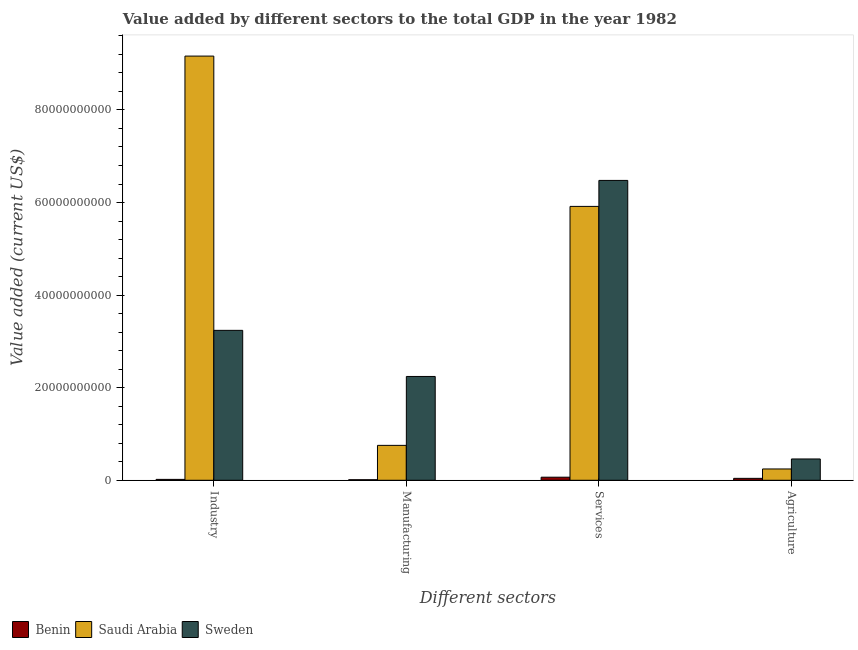How many groups of bars are there?
Provide a short and direct response. 4. Are the number of bars on each tick of the X-axis equal?
Offer a terse response. Yes. What is the label of the 2nd group of bars from the left?
Provide a succinct answer. Manufacturing. What is the value added by agricultural sector in Sweden?
Make the answer very short. 4.60e+09. Across all countries, what is the maximum value added by manufacturing sector?
Ensure brevity in your answer.  2.24e+1. Across all countries, what is the minimum value added by industrial sector?
Provide a short and direct response. 1.92e+08. In which country was the value added by services sector minimum?
Keep it short and to the point. Benin. What is the total value added by industrial sector in the graph?
Provide a succinct answer. 1.24e+11. What is the difference between the value added by agricultural sector in Benin and that in Saudi Arabia?
Provide a succinct answer. -2.03e+09. What is the difference between the value added by industrial sector in Saudi Arabia and the value added by agricultural sector in Sweden?
Offer a terse response. 8.70e+1. What is the average value added by industrial sector per country?
Your answer should be very brief. 4.14e+1. What is the difference between the value added by services sector and value added by industrial sector in Benin?
Your answer should be compact. 4.72e+08. In how many countries, is the value added by agricultural sector greater than 40000000000 US$?
Offer a very short reply. 0. What is the ratio of the value added by agricultural sector in Sweden to that in Saudi Arabia?
Offer a very short reply. 1.88. What is the difference between the highest and the second highest value added by agricultural sector?
Ensure brevity in your answer.  2.16e+09. What is the difference between the highest and the lowest value added by services sector?
Ensure brevity in your answer.  6.41e+1. Is the sum of the value added by industrial sector in Saudi Arabia and Benin greater than the maximum value added by manufacturing sector across all countries?
Ensure brevity in your answer.  Yes. Is it the case that in every country, the sum of the value added by agricultural sector and value added by industrial sector is greater than the sum of value added by manufacturing sector and value added by services sector?
Make the answer very short. No. What does the 1st bar from the right in Agriculture represents?
Your response must be concise. Sweden. How many bars are there?
Ensure brevity in your answer.  12. Does the graph contain any zero values?
Ensure brevity in your answer.  No. Where does the legend appear in the graph?
Make the answer very short. Bottom left. What is the title of the graph?
Ensure brevity in your answer.  Value added by different sectors to the total GDP in the year 1982. Does "Equatorial Guinea" appear as one of the legend labels in the graph?
Your response must be concise. No. What is the label or title of the X-axis?
Make the answer very short. Different sectors. What is the label or title of the Y-axis?
Keep it short and to the point. Value added (current US$). What is the Value added (current US$) of Benin in Industry?
Your answer should be compact. 1.92e+08. What is the Value added (current US$) of Saudi Arabia in Industry?
Provide a succinct answer. 9.16e+1. What is the Value added (current US$) in Sweden in Industry?
Ensure brevity in your answer.  3.24e+1. What is the Value added (current US$) in Benin in Manufacturing?
Make the answer very short. 1.15e+08. What is the Value added (current US$) in Saudi Arabia in Manufacturing?
Give a very brief answer. 7.54e+09. What is the Value added (current US$) of Sweden in Manufacturing?
Your response must be concise. 2.24e+1. What is the Value added (current US$) in Benin in Services?
Provide a short and direct response. 6.64e+08. What is the Value added (current US$) in Saudi Arabia in Services?
Make the answer very short. 5.92e+1. What is the Value added (current US$) in Sweden in Services?
Your answer should be compact. 6.48e+1. What is the Value added (current US$) of Benin in Agriculture?
Ensure brevity in your answer.  4.12e+08. What is the Value added (current US$) in Saudi Arabia in Agriculture?
Offer a very short reply. 2.44e+09. What is the Value added (current US$) of Sweden in Agriculture?
Provide a succinct answer. 4.60e+09. Across all Different sectors, what is the maximum Value added (current US$) of Benin?
Your answer should be very brief. 6.64e+08. Across all Different sectors, what is the maximum Value added (current US$) in Saudi Arabia?
Your answer should be compact. 9.16e+1. Across all Different sectors, what is the maximum Value added (current US$) of Sweden?
Provide a short and direct response. 6.48e+1. Across all Different sectors, what is the minimum Value added (current US$) of Benin?
Offer a very short reply. 1.15e+08. Across all Different sectors, what is the minimum Value added (current US$) in Saudi Arabia?
Provide a short and direct response. 2.44e+09. Across all Different sectors, what is the minimum Value added (current US$) of Sweden?
Provide a succinct answer. 4.60e+09. What is the total Value added (current US$) of Benin in the graph?
Provide a short and direct response. 1.38e+09. What is the total Value added (current US$) in Saudi Arabia in the graph?
Ensure brevity in your answer.  1.61e+11. What is the total Value added (current US$) of Sweden in the graph?
Keep it short and to the point. 1.24e+11. What is the difference between the Value added (current US$) in Benin in Industry and that in Manufacturing?
Offer a very short reply. 7.64e+07. What is the difference between the Value added (current US$) in Saudi Arabia in Industry and that in Manufacturing?
Give a very brief answer. 8.41e+1. What is the difference between the Value added (current US$) of Sweden in Industry and that in Manufacturing?
Keep it short and to the point. 9.96e+09. What is the difference between the Value added (current US$) of Benin in Industry and that in Services?
Offer a terse response. -4.72e+08. What is the difference between the Value added (current US$) in Saudi Arabia in Industry and that in Services?
Offer a terse response. 3.25e+1. What is the difference between the Value added (current US$) in Sweden in Industry and that in Services?
Your response must be concise. -3.24e+1. What is the difference between the Value added (current US$) in Benin in Industry and that in Agriculture?
Ensure brevity in your answer.  -2.20e+08. What is the difference between the Value added (current US$) of Saudi Arabia in Industry and that in Agriculture?
Ensure brevity in your answer.  8.92e+1. What is the difference between the Value added (current US$) in Sweden in Industry and that in Agriculture?
Your response must be concise. 2.78e+1. What is the difference between the Value added (current US$) of Benin in Manufacturing and that in Services?
Your response must be concise. -5.49e+08. What is the difference between the Value added (current US$) in Saudi Arabia in Manufacturing and that in Services?
Ensure brevity in your answer.  -5.16e+1. What is the difference between the Value added (current US$) in Sweden in Manufacturing and that in Services?
Provide a short and direct response. -4.24e+1. What is the difference between the Value added (current US$) in Benin in Manufacturing and that in Agriculture?
Give a very brief answer. -2.97e+08. What is the difference between the Value added (current US$) of Saudi Arabia in Manufacturing and that in Agriculture?
Ensure brevity in your answer.  5.10e+09. What is the difference between the Value added (current US$) of Sweden in Manufacturing and that in Agriculture?
Ensure brevity in your answer.  1.78e+1. What is the difference between the Value added (current US$) of Benin in Services and that in Agriculture?
Keep it short and to the point. 2.52e+08. What is the difference between the Value added (current US$) in Saudi Arabia in Services and that in Agriculture?
Ensure brevity in your answer.  5.67e+1. What is the difference between the Value added (current US$) of Sweden in Services and that in Agriculture?
Your answer should be compact. 6.02e+1. What is the difference between the Value added (current US$) of Benin in Industry and the Value added (current US$) of Saudi Arabia in Manufacturing?
Provide a short and direct response. -7.35e+09. What is the difference between the Value added (current US$) in Benin in Industry and the Value added (current US$) in Sweden in Manufacturing?
Your answer should be compact. -2.22e+1. What is the difference between the Value added (current US$) in Saudi Arabia in Industry and the Value added (current US$) in Sweden in Manufacturing?
Keep it short and to the point. 6.92e+1. What is the difference between the Value added (current US$) of Benin in Industry and the Value added (current US$) of Saudi Arabia in Services?
Make the answer very short. -5.90e+1. What is the difference between the Value added (current US$) of Benin in Industry and the Value added (current US$) of Sweden in Services?
Keep it short and to the point. -6.46e+1. What is the difference between the Value added (current US$) of Saudi Arabia in Industry and the Value added (current US$) of Sweden in Services?
Ensure brevity in your answer.  2.69e+1. What is the difference between the Value added (current US$) in Benin in Industry and the Value added (current US$) in Saudi Arabia in Agriculture?
Your response must be concise. -2.25e+09. What is the difference between the Value added (current US$) of Benin in Industry and the Value added (current US$) of Sweden in Agriculture?
Your answer should be very brief. -4.41e+09. What is the difference between the Value added (current US$) in Saudi Arabia in Industry and the Value added (current US$) in Sweden in Agriculture?
Your answer should be very brief. 8.70e+1. What is the difference between the Value added (current US$) in Benin in Manufacturing and the Value added (current US$) in Saudi Arabia in Services?
Your answer should be compact. -5.90e+1. What is the difference between the Value added (current US$) of Benin in Manufacturing and the Value added (current US$) of Sweden in Services?
Provide a short and direct response. -6.47e+1. What is the difference between the Value added (current US$) in Saudi Arabia in Manufacturing and the Value added (current US$) in Sweden in Services?
Offer a very short reply. -5.72e+1. What is the difference between the Value added (current US$) in Benin in Manufacturing and the Value added (current US$) in Saudi Arabia in Agriculture?
Give a very brief answer. -2.33e+09. What is the difference between the Value added (current US$) of Benin in Manufacturing and the Value added (current US$) of Sweden in Agriculture?
Your answer should be compact. -4.49e+09. What is the difference between the Value added (current US$) of Saudi Arabia in Manufacturing and the Value added (current US$) of Sweden in Agriculture?
Your response must be concise. 2.94e+09. What is the difference between the Value added (current US$) in Benin in Services and the Value added (current US$) in Saudi Arabia in Agriculture?
Provide a succinct answer. -1.78e+09. What is the difference between the Value added (current US$) in Benin in Services and the Value added (current US$) in Sweden in Agriculture?
Provide a short and direct response. -3.94e+09. What is the difference between the Value added (current US$) in Saudi Arabia in Services and the Value added (current US$) in Sweden in Agriculture?
Your response must be concise. 5.46e+1. What is the average Value added (current US$) of Benin per Different sectors?
Give a very brief answer. 3.46e+08. What is the average Value added (current US$) of Saudi Arabia per Different sectors?
Provide a short and direct response. 4.02e+1. What is the average Value added (current US$) in Sweden per Different sectors?
Make the answer very short. 3.10e+1. What is the difference between the Value added (current US$) of Benin and Value added (current US$) of Saudi Arabia in Industry?
Offer a terse response. -9.14e+1. What is the difference between the Value added (current US$) in Benin and Value added (current US$) in Sweden in Industry?
Offer a very short reply. -3.22e+1. What is the difference between the Value added (current US$) of Saudi Arabia and Value added (current US$) of Sweden in Industry?
Your response must be concise. 5.92e+1. What is the difference between the Value added (current US$) in Benin and Value added (current US$) in Saudi Arabia in Manufacturing?
Your answer should be very brief. -7.42e+09. What is the difference between the Value added (current US$) in Benin and Value added (current US$) in Sweden in Manufacturing?
Ensure brevity in your answer.  -2.23e+1. What is the difference between the Value added (current US$) in Saudi Arabia and Value added (current US$) in Sweden in Manufacturing?
Offer a very short reply. -1.49e+1. What is the difference between the Value added (current US$) of Benin and Value added (current US$) of Saudi Arabia in Services?
Make the answer very short. -5.85e+1. What is the difference between the Value added (current US$) of Benin and Value added (current US$) of Sweden in Services?
Keep it short and to the point. -6.41e+1. What is the difference between the Value added (current US$) in Saudi Arabia and Value added (current US$) in Sweden in Services?
Ensure brevity in your answer.  -5.61e+09. What is the difference between the Value added (current US$) of Benin and Value added (current US$) of Saudi Arabia in Agriculture?
Your response must be concise. -2.03e+09. What is the difference between the Value added (current US$) in Benin and Value added (current US$) in Sweden in Agriculture?
Provide a short and direct response. -4.19e+09. What is the difference between the Value added (current US$) of Saudi Arabia and Value added (current US$) of Sweden in Agriculture?
Offer a terse response. -2.16e+09. What is the ratio of the Value added (current US$) of Benin in Industry to that in Manufacturing?
Your answer should be very brief. 1.66. What is the ratio of the Value added (current US$) in Saudi Arabia in Industry to that in Manufacturing?
Offer a terse response. 12.16. What is the ratio of the Value added (current US$) of Sweden in Industry to that in Manufacturing?
Offer a very short reply. 1.44. What is the ratio of the Value added (current US$) in Benin in Industry to that in Services?
Ensure brevity in your answer.  0.29. What is the ratio of the Value added (current US$) in Saudi Arabia in Industry to that in Services?
Your answer should be compact. 1.55. What is the ratio of the Value added (current US$) in Sweden in Industry to that in Services?
Ensure brevity in your answer.  0.5. What is the ratio of the Value added (current US$) of Benin in Industry to that in Agriculture?
Provide a succinct answer. 0.47. What is the ratio of the Value added (current US$) in Saudi Arabia in Industry to that in Agriculture?
Your answer should be compact. 37.52. What is the ratio of the Value added (current US$) in Sweden in Industry to that in Agriculture?
Offer a very short reply. 7.04. What is the ratio of the Value added (current US$) of Benin in Manufacturing to that in Services?
Keep it short and to the point. 0.17. What is the ratio of the Value added (current US$) of Saudi Arabia in Manufacturing to that in Services?
Provide a short and direct response. 0.13. What is the ratio of the Value added (current US$) of Sweden in Manufacturing to that in Services?
Keep it short and to the point. 0.35. What is the ratio of the Value added (current US$) in Benin in Manufacturing to that in Agriculture?
Make the answer very short. 0.28. What is the ratio of the Value added (current US$) of Saudi Arabia in Manufacturing to that in Agriculture?
Ensure brevity in your answer.  3.09. What is the ratio of the Value added (current US$) of Sweden in Manufacturing to that in Agriculture?
Your answer should be very brief. 4.87. What is the ratio of the Value added (current US$) in Benin in Services to that in Agriculture?
Your answer should be very brief. 1.61. What is the ratio of the Value added (current US$) in Saudi Arabia in Services to that in Agriculture?
Keep it short and to the point. 24.23. What is the ratio of the Value added (current US$) in Sweden in Services to that in Agriculture?
Your answer should be very brief. 14.08. What is the difference between the highest and the second highest Value added (current US$) in Benin?
Provide a short and direct response. 2.52e+08. What is the difference between the highest and the second highest Value added (current US$) of Saudi Arabia?
Offer a very short reply. 3.25e+1. What is the difference between the highest and the second highest Value added (current US$) of Sweden?
Provide a short and direct response. 3.24e+1. What is the difference between the highest and the lowest Value added (current US$) of Benin?
Offer a very short reply. 5.49e+08. What is the difference between the highest and the lowest Value added (current US$) of Saudi Arabia?
Your answer should be compact. 8.92e+1. What is the difference between the highest and the lowest Value added (current US$) in Sweden?
Provide a succinct answer. 6.02e+1. 